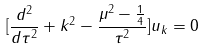Convert formula to latex. <formula><loc_0><loc_0><loc_500><loc_500>[ \frac { d ^ { 2 } } { d \tau ^ { 2 } } + k ^ { 2 } - \frac { \mu ^ { 2 } - \frac { 1 } { 4 } } { \tau ^ { 2 } } ] u _ { k } = 0</formula> 